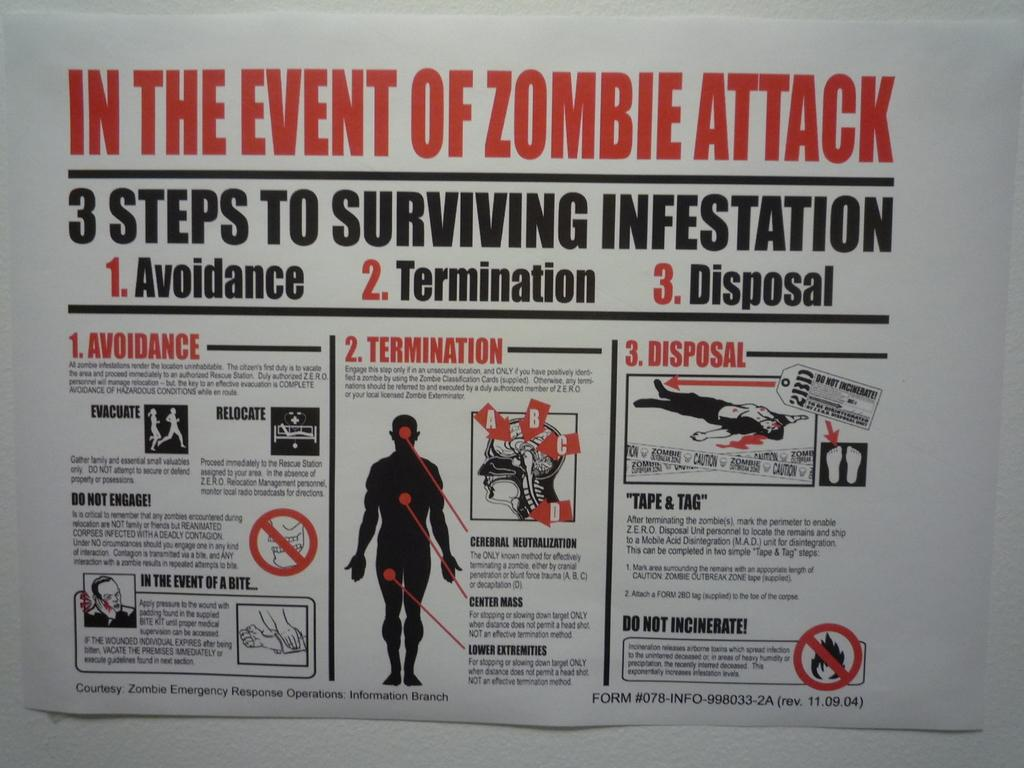<image>
Give a short and clear explanation of the subsequent image. In the Event of Zombie Attack poster to survive the attack. 